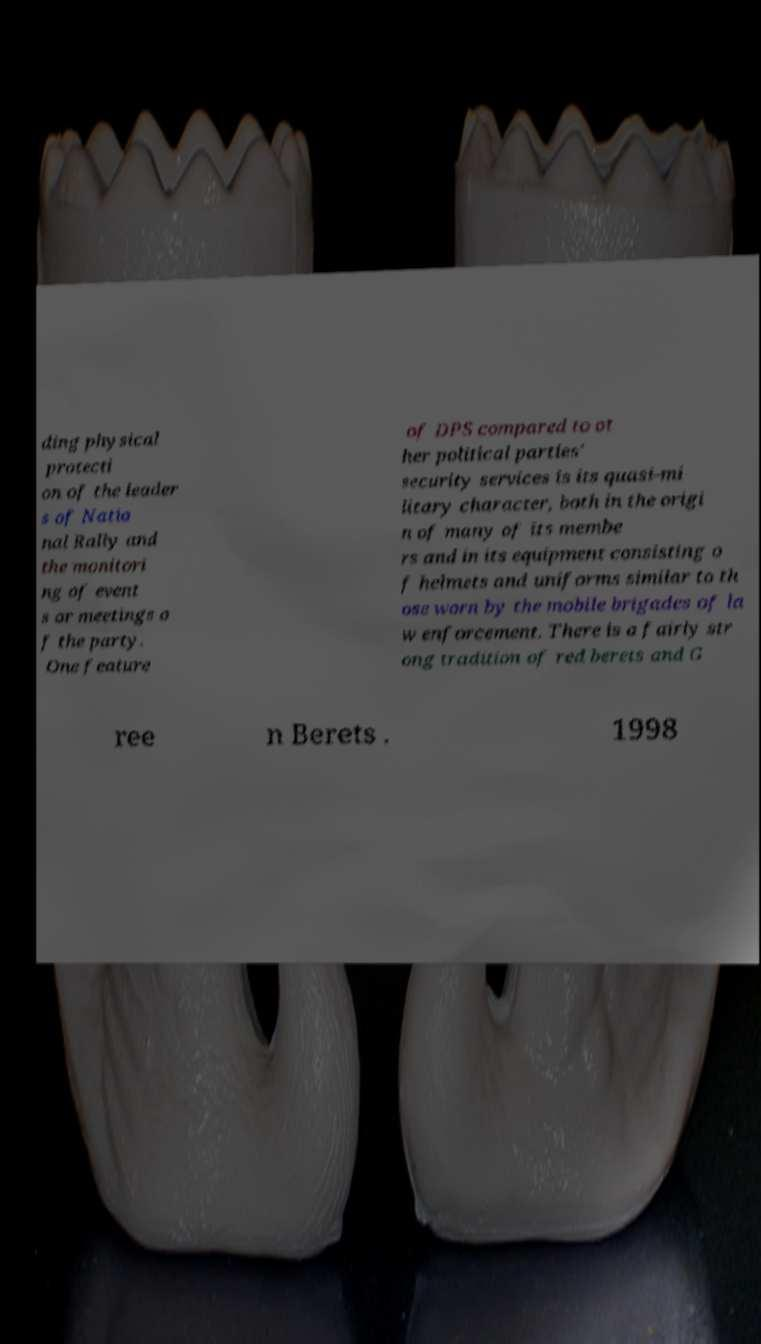I need the written content from this picture converted into text. Can you do that? ding physical protecti on of the leader s of Natio nal Rally and the monitori ng of event s or meetings o f the party. One feature of DPS compared to ot her political parties' security services is its quasi-mi litary character, both in the origi n of many of its membe rs and in its equipment consisting o f helmets and uniforms similar to th ose worn by the mobile brigades of la w enforcement. There is a fairly str ong tradition of red berets and G ree n Berets . 1998 